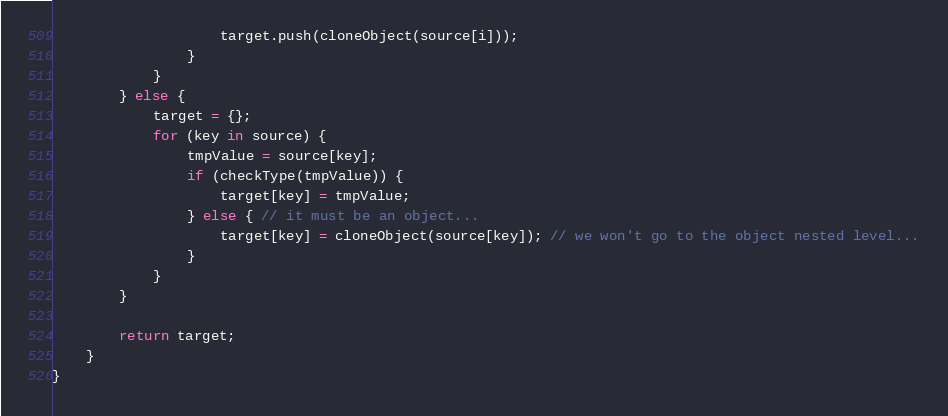Convert code to text. <code><loc_0><loc_0><loc_500><loc_500><_TypeScript_>                    target.push(cloneObject(source[i]));
                }
            }
        } else {
            target = {};
            for (key in source) {
                tmpValue = source[key];
                if (checkType(tmpValue)) {
                    target[key] = tmpValue;
                } else { // it must be an object...
                    target[key] = cloneObject(source[key]); // we won't go to the object nested level...
                }
            }
        }

        return target;
    }
}
</code> 